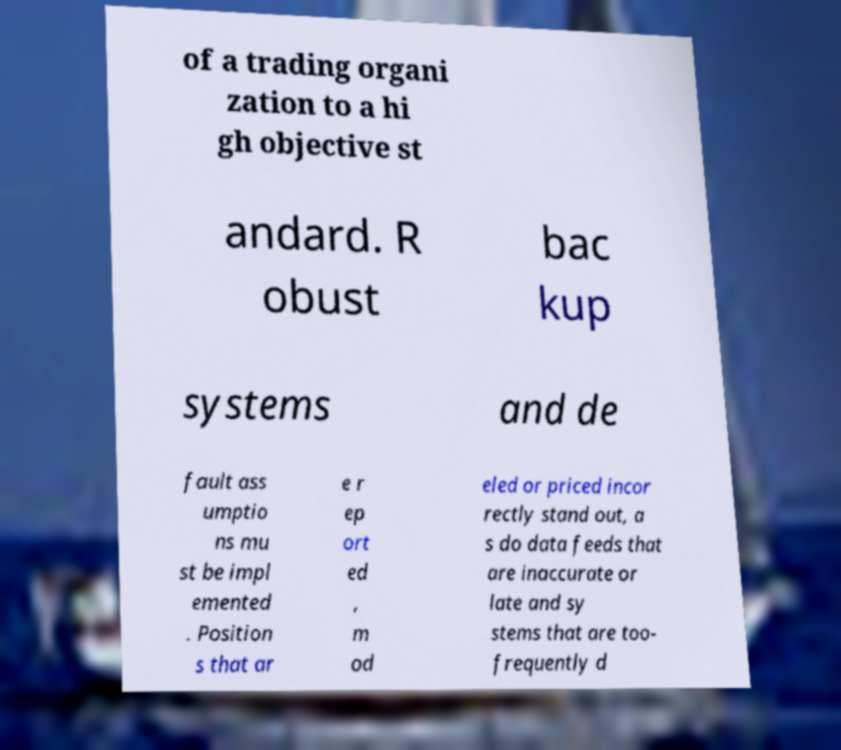I need the written content from this picture converted into text. Can you do that? of a trading organi zation to a hi gh objective st andard. R obust bac kup systems and de fault ass umptio ns mu st be impl emented . Position s that ar e r ep ort ed , m od eled or priced incor rectly stand out, a s do data feeds that are inaccurate or late and sy stems that are too- frequently d 